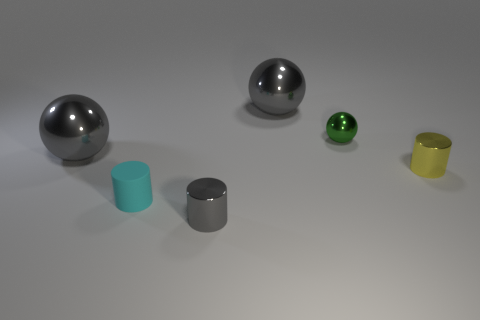Are these objects meant to represent anything specific or do they serve a utilitarian purpose? These objects do not appear to represent anything specific and are likely for illustrative purposes to demonstrate different sizes, colors, and materials, possibly for a visual arts project or educational demonstration. 